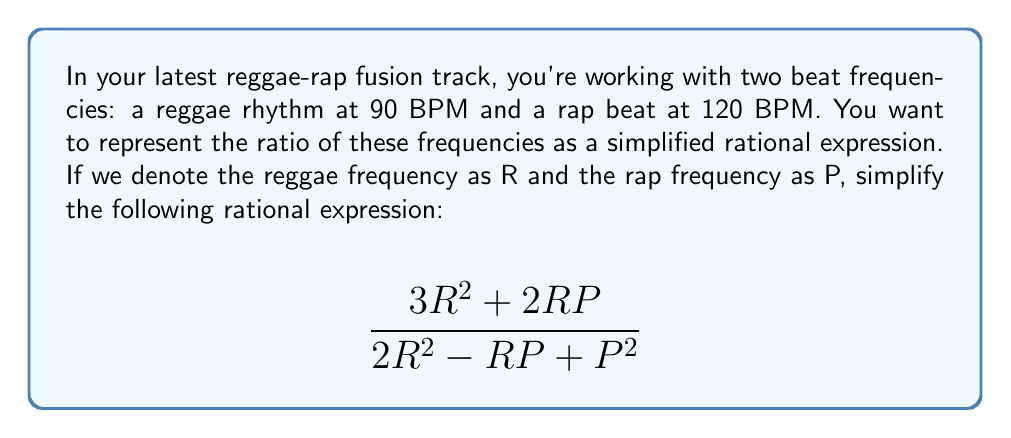Could you help me with this problem? Let's simplify this rational expression step-by-step:

1) First, we can factor out the greatest common factor (GCF) from both the numerator and denominator.
   In the numerator: GCF = R
   In the denominator: There is no common factor

   $$\frac{R(3R + 2P)}{2R^2 - RP + P^2}$$

2) Now, we need to check if there are any common factors between the numerator and denominator.
   The numerator is $R(3R + 2P)$
   The denominator is $2R^2 - RP + P^2$

3) We can factor the denominator:
   $2R^2 - RP + P^2 = (R - P)(2R + P)$

4) Now our expression looks like:

   $$\frac{R(3R + 2P)}{(R - P)(2R + P)}$$

5) We can see that there are no common factors between the numerator and denominator.

6) Therefore, this is the simplified form of the rational expression.

7) To get the numerical value, we can substitute R = 90 and P = 120:

   $$\frac{90(3(90) + 2(120))}{(90 - 120)(2(90) + 120)} = \frac{90(270 + 240)}{(-30)(300)} = \frac{45900}{-9000} = -\frac{51}{10}$$
Answer: $\frac{R(3R + 2P)}{(R - P)(2R + P)}$ or $-\frac{51}{10}$ when R = 90 and P = 120 